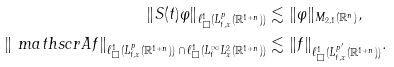<formula> <loc_0><loc_0><loc_500><loc_500>\left \| S ( t ) \varphi \right \| _ { \ell ^ { 1 } _ { \Box } ( L ^ { p } _ { t , x } ( \mathbb { R } ^ { 1 + n } ) ) } & \lesssim \| \varphi \| _ { M _ { 2 , 1 } ( \mathbb { R } ^ { n } ) } , \\ \left \| \ m a t h s c r { A } f \right \| _ { \ell ^ { 1 } _ { \Box } ( L ^ { p } _ { t , x } ( \mathbb { R } ^ { 1 + n } ) ) \, \cap \, \ell ^ { 1 } _ { \Box } ( L ^ { \infty } _ { t } L ^ { 2 } _ { x } ( \mathbb { R } ^ { 1 + n } ) ) } & \lesssim \| f \| _ { \ell ^ { 1 } _ { \Box } ( L ^ { p ^ { \prime } } _ { t , x } ( \mathbb { R } ^ { 1 + n } ) ) } .</formula> 